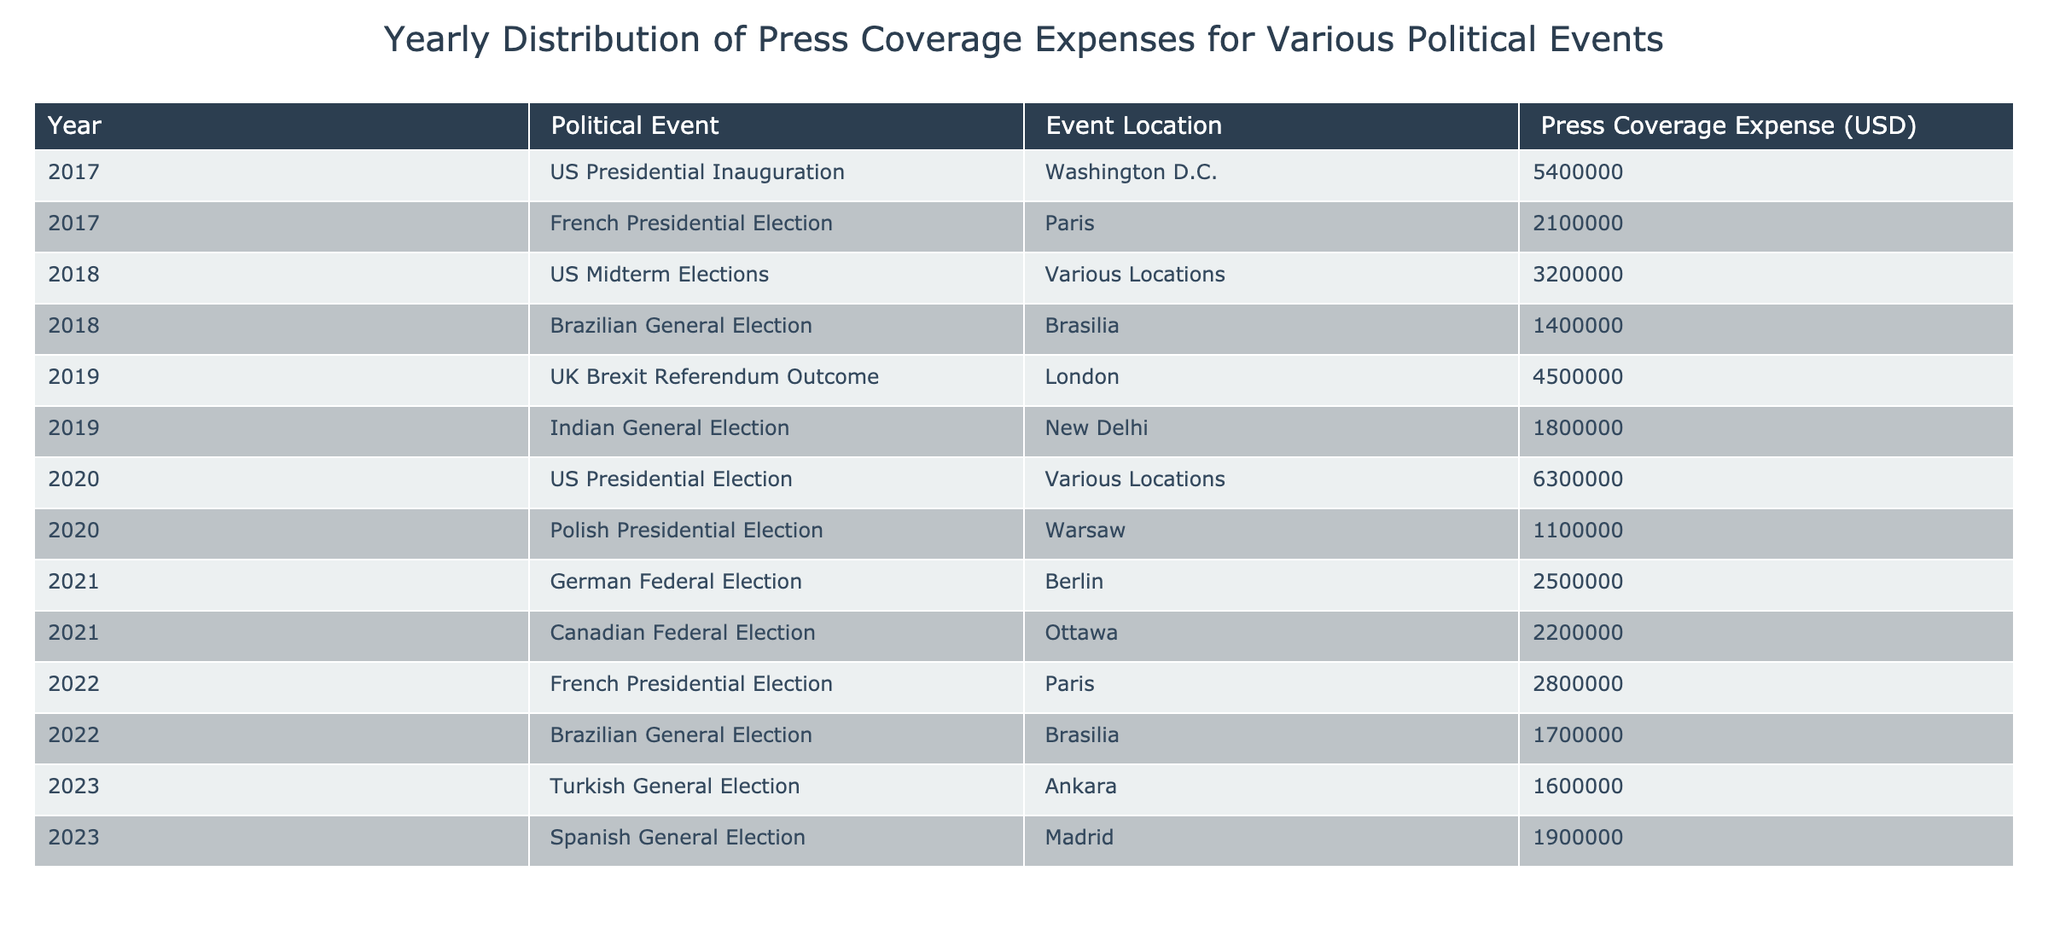What was the press coverage expense for the US Presidential Election in 2020? The row corresponding to the US Presidential Election in 2020 shows that the press coverage expense was 6300000 USD.
Answer: 6300000 USD Which political event had the highest press coverage expense and what was that amount? The US Presidential Election in 2020 had the highest press coverage expense, which was 6300000 USD.
Answer: 6300000 USD What was the total press coverage expense for all events in 2019? The total for 2019 is obtained by adding the expenses of two events: UK Brexit Referendum Outcome (4500000 USD) and Indian General Election (1800000 USD). The sum is 4500000 + 1800000 = 6300000 USD.
Answer: 6300000 USD Is the press coverage expense for the German Federal Election in 2021 greater than for the Canadian Federal Election in the same year? The expense for both events is compared: German Federal Election was 2500000 USD and Canadian Federal Election was 2200000 USD. Hence, 2500000 > 2200000 is true.
Answer: Yes What is the average press coverage expense for the Brazilian General Elections listed in the table? The expenses for Brazilian General Elections are 1400000 USD in 2018 and 1700000 USD in 2022. The average is calculated as (1400000 + 1700000) / 2 = 1550000 USD.
Answer: 1550000 USD How many political events had press coverage expenses of over 2000000 USD? By examining the table, the events that had expenses greater than 2000000 USD are: US Presidential Inauguration (5400000 USD), French Presidential Election (2100000 USD), US Midterm Elections (3200000 USD), UK Brexit Referendum Outcome (4500000 USD), Indian General Election (1800000 USD), US Presidential Election (6300000 USD), German Federal Election (2500000 USD), and French Presidential Election (2800000 USD). Counting these, there are 6 events.
Answer: 6 What was the difference in press coverage expenses between the US Presidential Election in 2020 and the French Presidential Election in 2022? The difference is calculated as the press coverage expense for the US Presidential Election (6300000 USD) minus that for the French Presidential Election (2800000 USD): 6300000 - 2800000 = 3500000 USD.
Answer: 3500000 USD Which year had the least total press coverage expense? By summing up each year's expenses, we find: 2017 = 7500000 USD, 2018 = 4600000 USD, 2019 = 6300000 USD, 2020 = 7400000 USD, 2021 = 4700000 USD, 2022 = 4500000 USD, and 2023 = 3500000 USD. The least total expense was for 2023 with 3500000 USD.
Answer: 2023 How many political events in this data took place in Paris? The events that took place in Paris are the French Presidential Election in 2017 and 2022. Counting these events gives us 2 events.
Answer: 2 